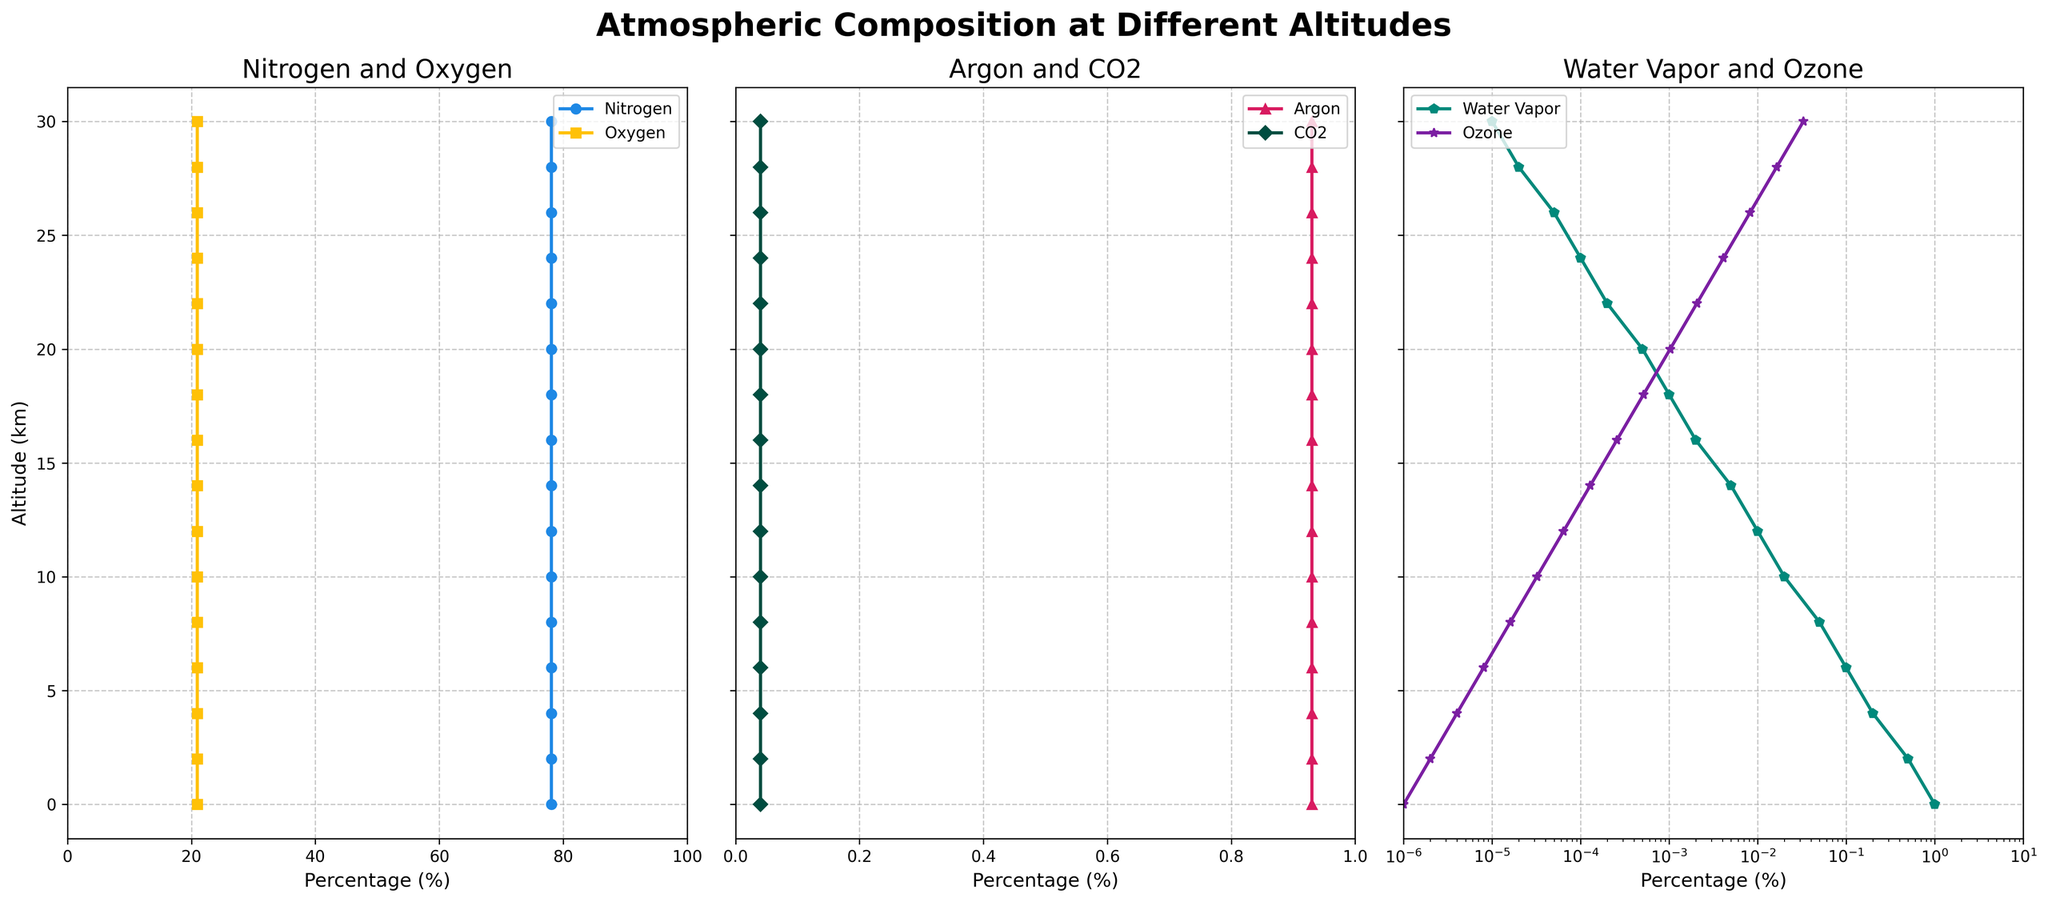Which gas has a constant percentage across all altitudes? Nitrogen and oxygen both have percentages that do not change with altitude, remaining constant at 78.08% and 20.95%, respectively.
Answer: Nitrogen and oxygen What happens to the percentage of water vapor as altitude increases from 0 km to 30 km? The percentage of water vapor decreases significantly as altitude increases. At 0 km, it is 1.0%, and at 30 km, it drops to 0.00001%.
Answer: It decreases How does the concentration of ozone change from 0 km to 30 km? The concentration of ozone increases exponentially with altitude. At 0 km, it is 0.000001%, and by 30 km, it reaches 0.032768%.
Answer: It increases At what altitude does the concentration of water vapor drop below 0.1%? The concentration of water vapor falls below 0.1% at an altitude of 6 km.
Answer: 6 km Compare the concentration of carbon dioxide (CO2) and argon (Ar) at 20 km altitude. Which one is higher? At 20 km, the concentration of Argon is 0.93%, while the concentration of CO2 is 0.04%. Therefore, argon has a higher concentration.
Answer: Argon What is the percentage increase in ozone concentration from 18 km to 20 km? The ozone concentration at 18 km is 0.000512% and at 20 km is 0.001024%. The percentage increase is ((0.001024 - 0.000512) / 0.000512) * 100 = 100%.
Answer: 100% How do the trends of nitrogen and oxygen compare as altitude increases? Both nitrogen and oxygen percentages remain constant at 78.08% and 20.95%, respectively, showing no variation with altitude.
Answer: They remain constant Between 10 km and 20 km, which gas shows the most significant change in concentration? Ozone shows the most significant change in concentration, increasing from 0.000032% at 10 km to 0.001024% at 20 km.
Answer: Ozone At which altitude is the percentage of ozone equal to the percentage of water vapor? At 22 km, the percentage of ozone (0.002048%) is approximately equal to the percentage of water vapor (0.0002%).
Answer: 22 km Which gases are most affected by changes in altitude, and which are unaffected? Water vapor and ozone are most affected by changes in altitude, showing significant variation. Nitrogen and oxygen remain unaffected.
Answer: Water vapor and ozone (affected); Nitrogen and oxygen (unaffected) 